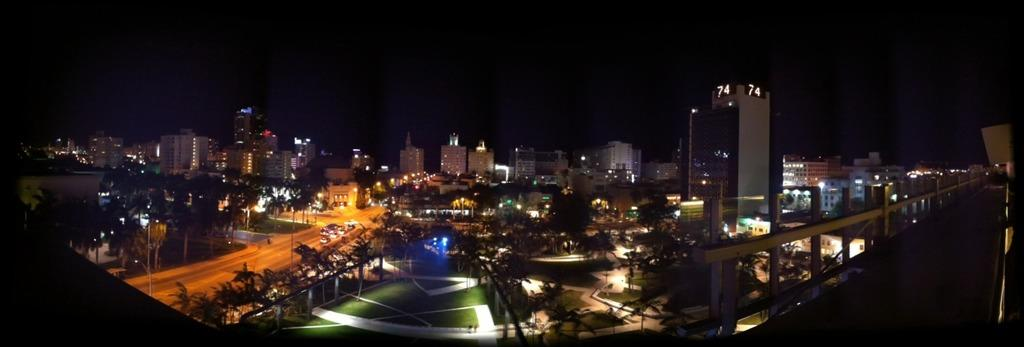What type of view is shown in the image? The image is a top view of a city. What structures can be seen in the image? There are buildings in the image. What connects the buildings in the image? There are roads in the image. What type of vegetation is present in the image? There are trees in the image. What additional features can be seen in the image? There are lampposts in the image. Can you hear the hydrant laughing in the image? There is no hydrant present in the image, and therefore it cannot be heard laughing. 